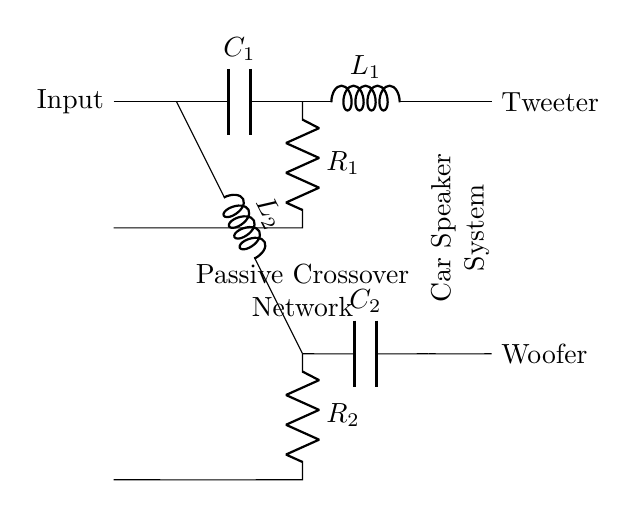What type of components are used in this circuit? The circuit uses capacitors, inductors, and resistors, which are defined as RLC components.
Answer: RLC components What does the high-pass filter branch consist of? The high-pass filter consists of a capacitor in series with an inductor; the capacitor allows high frequencies to pass through while blocking low frequencies.
Answer: Capacitor and inductor What is the purpose of the resistors in this circuit? The resistors help to control the gain of the signal, reduce power levels, and protect the components by limiting current flow.
Answer: Control gain Which speaker is connected to the high-pass filter? The tweeter is connected to the high-pass filter, receiving high-frequency signals.
Answer: Tweeter What happens to frequencies below the cutoff in the low-pass filter? Frequencies below the cutoff are allowed to pass through to the woofer, while higher frequencies are blocked.
Answer: Allowed to pass How many branches are present in the passive crossover network? There are two distinct branches: one for the high-pass filter and one for the low-pass filter, allowing separation of frequencies for different speakers.
Answer: Two branches What is the role of the inductor in the low-pass filter? The inductor in the low-pass filter blocks high-frequency signals and allows low frequencies to pass through to the woofer, enhancing sound quality.
Answer: Block high frequencies 